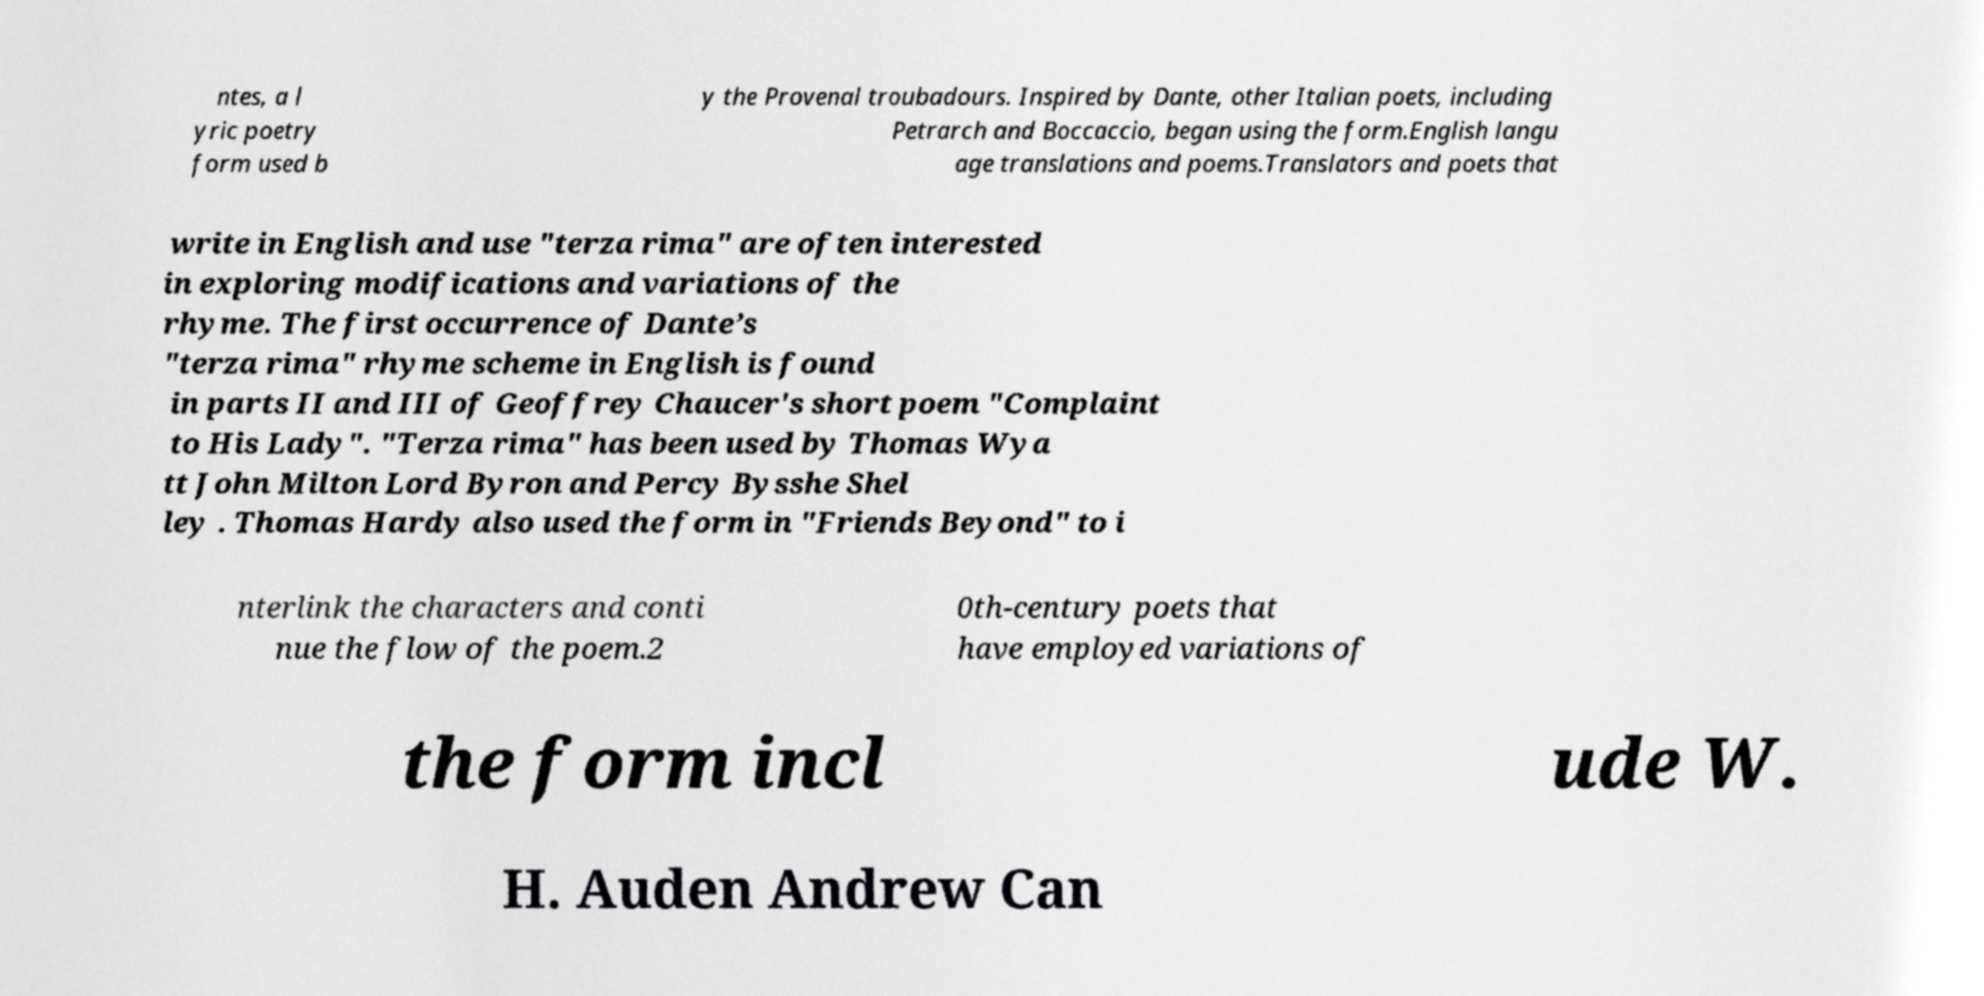Could you extract and type out the text from this image? ntes, a l yric poetry form used b y the Provenal troubadours. Inspired by Dante, other Italian poets, including Petrarch and Boccaccio, began using the form.English langu age translations and poems.Translators and poets that write in English and use "terza rima" are often interested in exploring modifications and variations of the rhyme. The first occurrence of Dante’s "terza rima" rhyme scheme in English is found in parts II and III of Geoffrey Chaucer's short poem "Complaint to His Lady". "Terza rima" has been used by Thomas Wya tt John Milton Lord Byron and Percy Bysshe Shel ley . Thomas Hardy also used the form in "Friends Beyond" to i nterlink the characters and conti nue the flow of the poem.2 0th-century poets that have employed variations of the form incl ude W. H. Auden Andrew Can 